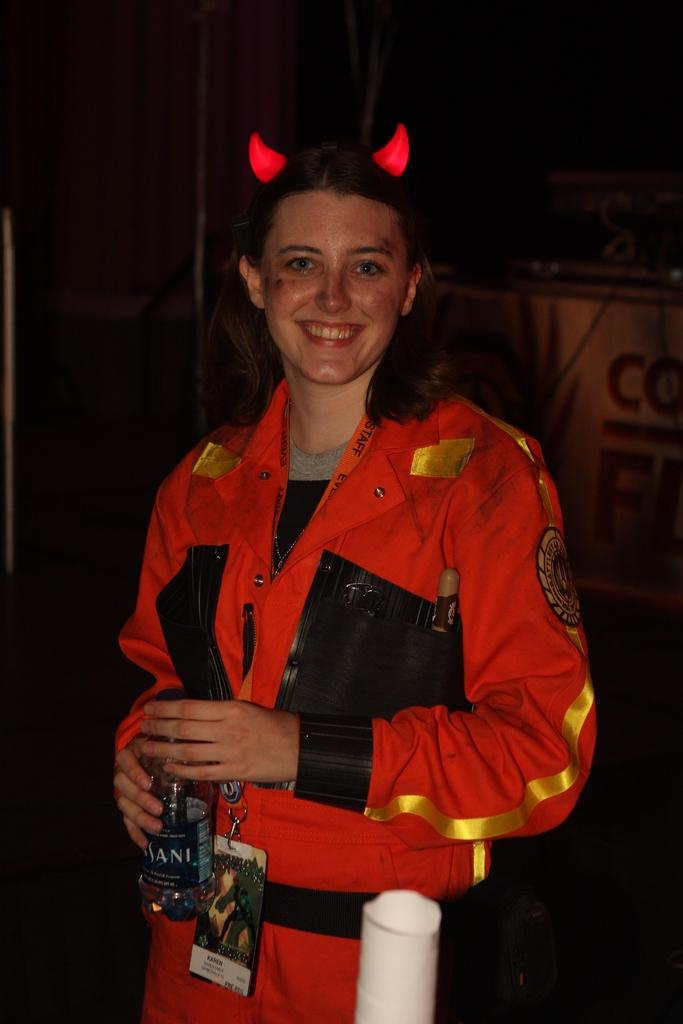Who is the main subject in the image? There is a woman in the image. What is the woman wearing? The woman is wearing a jacket. What is unique about the woman's appearance? The woman has horns on her head. What expression does the woman have? The woman is smiling. What is the woman holding in her hand? The woman is holding a bottle in her hand. What can be observed about the background of the image? The background of the image is dark. What type of songs can be heard coming from the woman's nose in the image? There is no indication in the image that the woman's nose is producing any songs, as the image only shows her holding a bottle and smiling. 